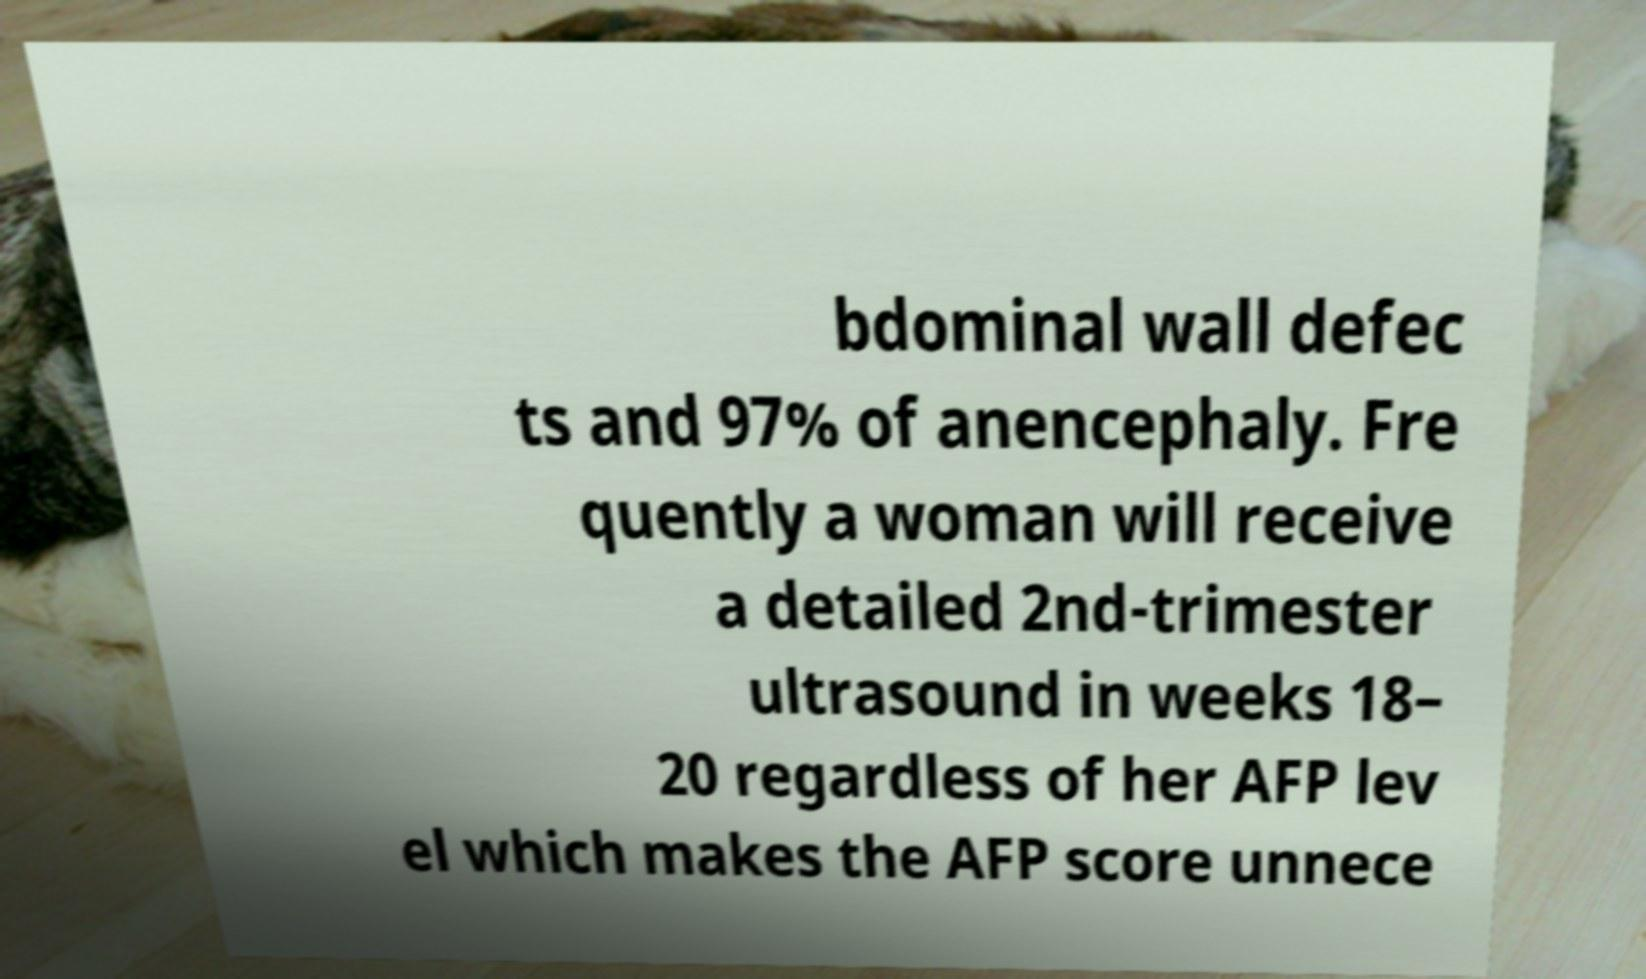There's text embedded in this image that I need extracted. Can you transcribe it verbatim? bdominal wall defec ts and 97% of anencephaly. Fre quently a woman will receive a detailed 2nd-trimester ultrasound in weeks 18– 20 regardless of her AFP lev el which makes the AFP score unnece 